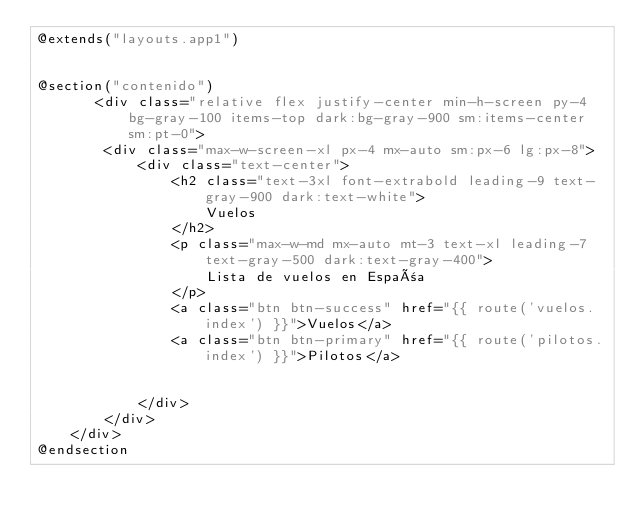<code> <loc_0><loc_0><loc_500><loc_500><_PHP_>@extends("layouts.app1")


@section("contenido")
       <div class="relative flex justify-center min-h-screen py-4 bg-gray-100 items-top dark:bg-gray-900 sm:items-center sm:pt-0">
        <div class="max-w-screen-xl px-4 mx-auto sm:px-6 lg:px-8">
            <div class="text-center">
                <h2 class="text-3xl font-extrabold leading-9 text-gray-900 dark:text-white">
                    Vuelos
                </h2>
                <p class="max-w-md mx-auto mt-3 text-xl leading-7 text-gray-500 dark:text-gray-400">
                    Lista de vuelos en España
                </p>
                <a class="btn btn-success" href="{{ route('vuelos.index') }}">Vuelos</a>
                <a class="btn btn-primary" href="{{ route('pilotos.index') }}">Pilotos</a>


            </div>
        </div>
    </div>
@endsection
</code> 